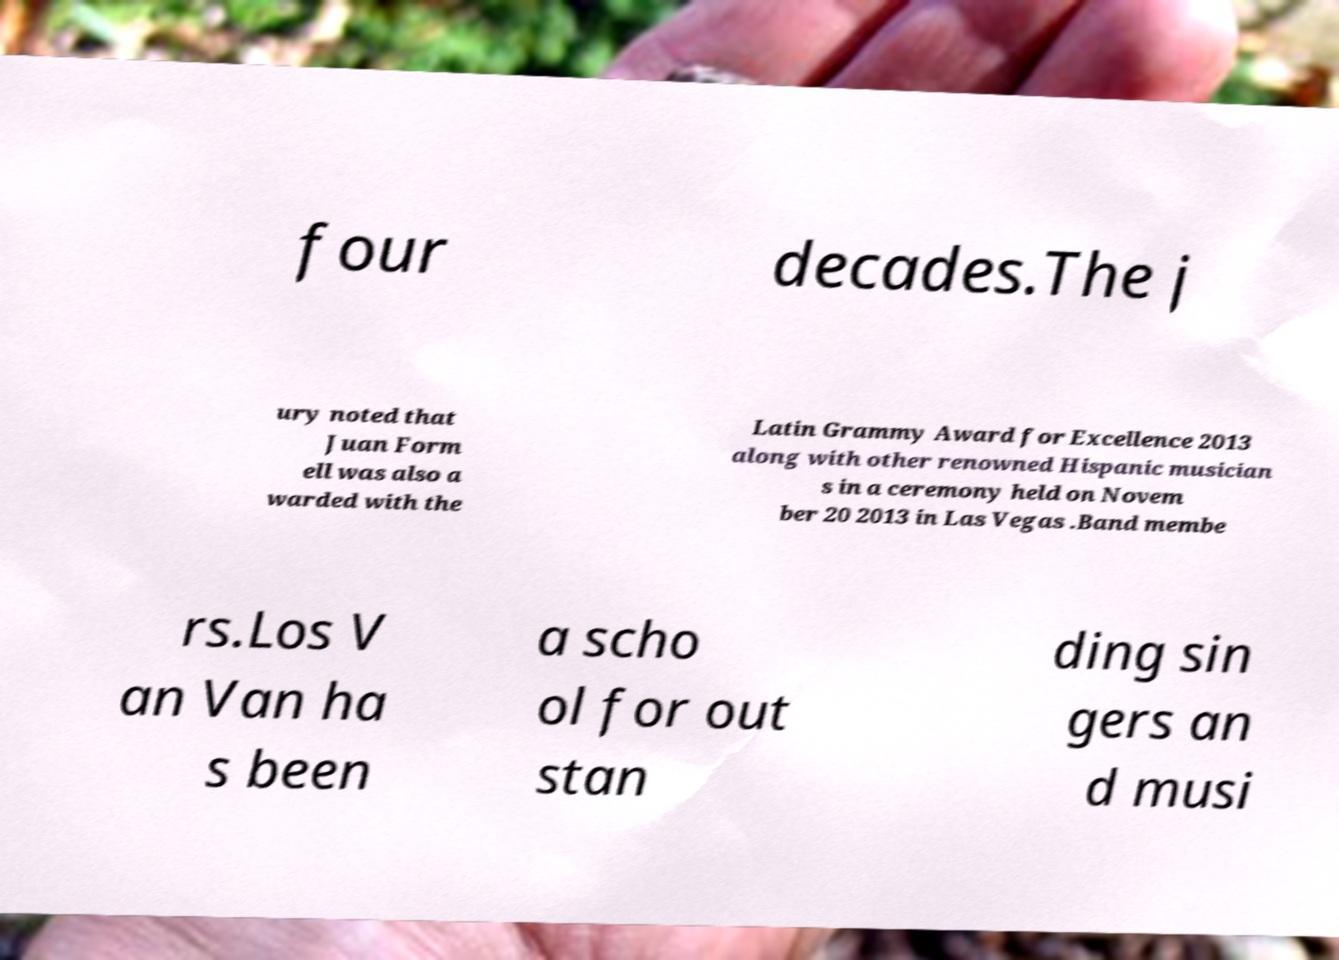Could you extract and type out the text from this image? four decades.The j ury noted that Juan Form ell was also a warded with the Latin Grammy Award for Excellence 2013 along with other renowned Hispanic musician s in a ceremony held on Novem ber 20 2013 in Las Vegas .Band membe rs.Los V an Van ha s been a scho ol for out stan ding sin gers an d musi 